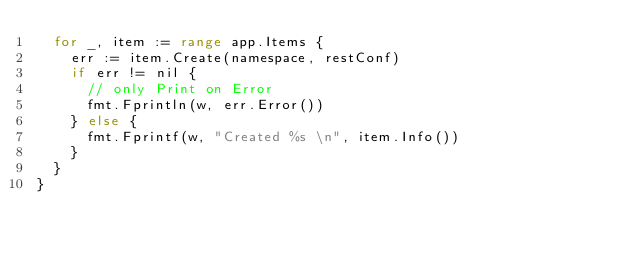<code> <loc_0><loc_0><loc_500><loc_500><_Go_>	for _, item := range app.Items {
		err := item.Create(namespace, restConf)
		if err != nil {
			// only Print on Error
			fmt.Fprintln(w, err.Error())
		} else {
			fmt.Fprintf(w, "Created %s \n", item.Info())
		}
	}
}
</code> 